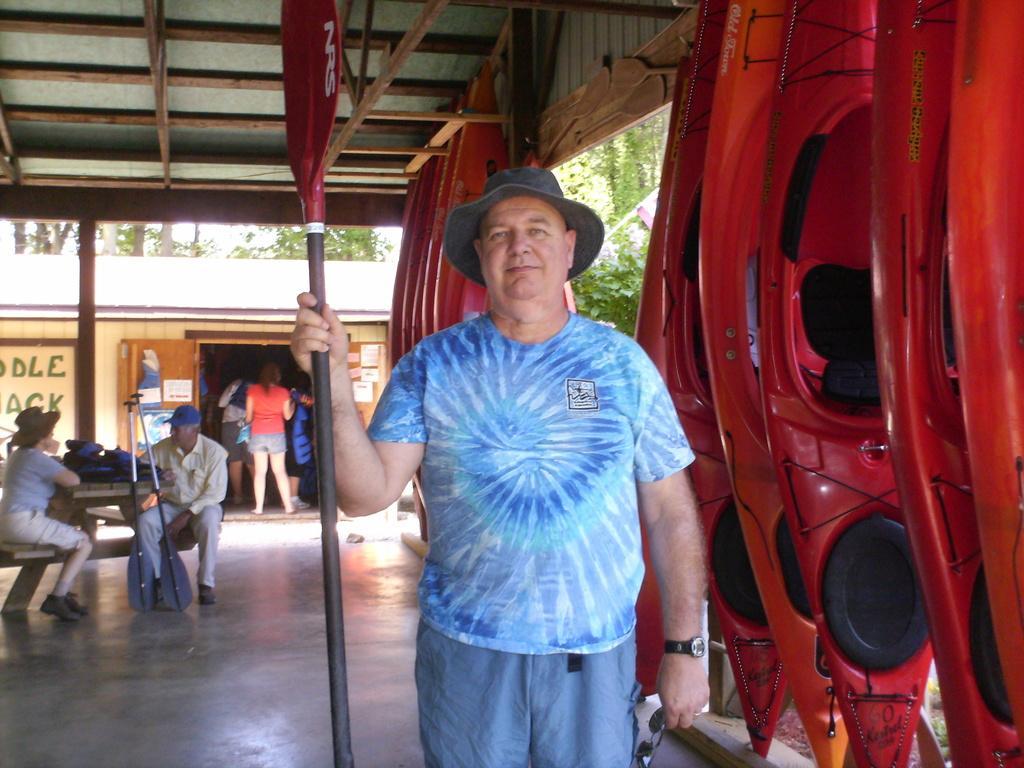Could you give a brief overview of what you see in this image? In this image we can see there is a shed, in the shed there is a person holding a paddle and spectacles and there are plastic boats. There are persons sitting on the bench, in front there is a table, on the table there is a bag. At the back there is a building and persons standing in it. And there are trees. 